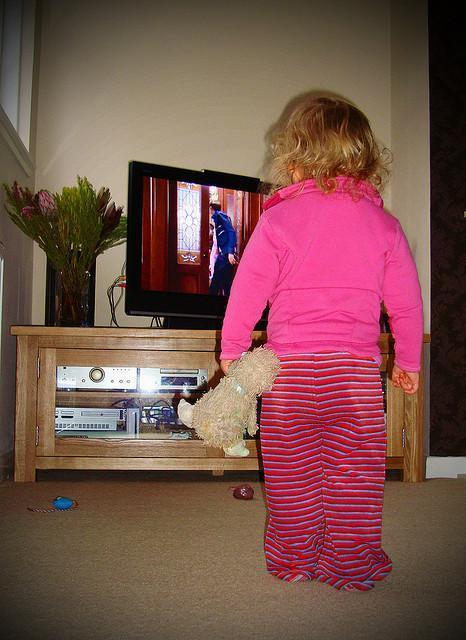How many kids are there?
Give a very brief answer. 1. How many beds are in this room?
Give a very brief answer. 0. 